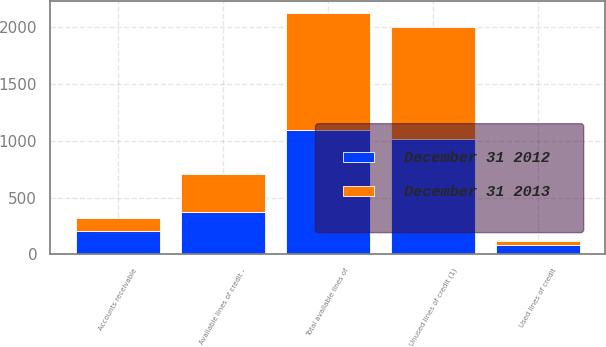<chart> <loc_0><loc_0><loc_500><loc_500><stacked_bar_chart><ecel><fcel>Used lines of credit<fcel>Unused lines of credit (1)<fcel>Total available lines of<fcel>Available lines of credit -<fcel>Accounts receivable<nl><fcel>December 31 2012<fcel>81.6<fcel>1015<fcel>1096.6<fcel>374.7<fcel>209<nl><fcel>December 31 2013<fcel>39.2<fcel>989.5<fcel>1028.7<fcel>328.2<fcel>112<nl></chart> 